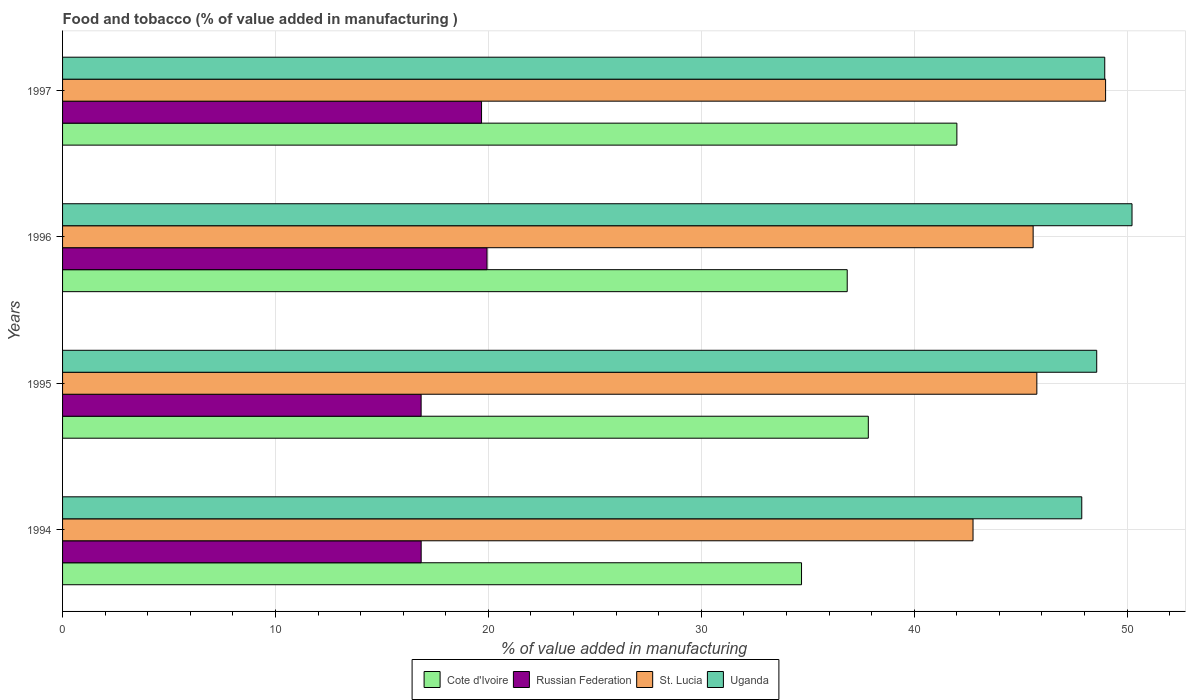How many different coloured bars are there?
Your answer should be very brief. 4. How many groups of bars are there?
Provide a succinct answer. 4. Are the number of bars per tick equal to the number of legend labels?
Ensure brevity in your answer.  Yes. How many bars are there on the 4th tick from the top?
Your answer should be compact. 4. In how many cases, is the number of bars for a given year not equal to the number of legend labels?
Ensure brevity in your answer.  0. What is the value added in manufacturing food and tobacco in Russian Federation in 1997?
Keep it short and to the point. 19.68. Across all years, what is the maximum value added in manufacturing food and tobacco in Uganda?
Make the answer very short. 50.23. Across all years, what is the minimum value added in manufacturing food and tobacco in St. Lucia?
Your answer should be compact. 42.76. In which year was the value added in manufacturing food and tobacco in Uganda maximum?
Your response must be concise. 1996. In which year was the value added in manufacturing food and tobacco in Cote d'Ivoire minimum?
Offer a very short reply. 1994. What is the total value added in manufacturing food and tobacco in Cote d'Ivoire in the graph?
Offer a very short reply. 151.42. What is the difference between the value added in manufacturing food and tobacco in Uganda in 1994 and that in 1995?
Offer a very short reply. -0.7. What is the difference between the value added in manufacturing food and tobacco in Russian Federation in 1994 and the value added in manufacturing food and tobacco in Cote d'Ivoire in 1997?
Offer a very short reply. -25.16. What is the average value added in manufacturing food and tobacco in Cote d'Ivoire per year?
Your answer should be compact. 37.85. In the year 1995, what is the difference between the value added in manufacturing food and tobacco in Cote d'Ivoire and value added in manufacturing food and tobacco in Russian Federation?
Offer a terse response. 21. What is the ratio of the value added in manufacturing food and tobacco in Cote d'Ivoire in 1995 to that in 1996?
Ensure brevity in your answer.  1.03. Is the difference between the value added in manufacturing food and tobacco in Cote d'Ivoire in 1995 and 1997 greater than the difference between the value added in manufacturing food and tobacco in Russian Federation in 1995 and 1997?
Give a very brief answer. No. What is the difference between the highest and the second highest value added in manufacturing food and tobacco in St. Lucia?
Give a very brief answer. 3.23. What is the difference between the highest and the lowest value added in manufacturing food and tobacco in St. Lucia?
Make the answer very short. 6.23. In how many years, is the value added in manufacturing food and tobacco in St. Lucia greater than the average value added in manufacturing food and tobacco in St. Lucia taken over all years?
Give a very brief answer. 1. Is the sum of the value added in manufacturing food and tobacco in Cote d'Ivoire in 1994 and 1995 greater than the maximum value added in manufacturing food and tobacco in Uganda across all years?
Make the answer very short. Yes. Is it the case that in every year, the sum of the value added in manufacturing food and tobacco in Cote d'Ivoire and value added in manufacturing food and tobacco in Uganda is greater than the sum of value added in manufacturing food and tobacco in St. Lucia and value added in manufacturing food and tobacco in Russian Federation?
Offer a terse response. Yes. What does the 2nd bar from the top in 1994 represents?
Provide a short and direct response. St. Lucia. What does the 1st bar from the bottom in 1997 represents?
Your response must be concise. Cote d'Ivoire. Is it the case that in every year, the sum of the value added in manufacturing food and tobacco in Russian Federation and value added in manufacturing food and tobacco in St. Lucia is greater than the value added in manufacturing food and tobacco in Uganda?
Your response must be concise. Yes. What is the difference between two consecutive major ticks on the X-axis?
Give a very brief answer. 10. How are the legend labels stacked?
Offer a very short reply. Horizontal. What is the title of the graph?
Your answer should be compact. Food and tobacco (% of value added in manufacturing ). Does "Mauritania" appear as one of the legend labels in the graph?
Provide a short and direct response. No. What is the label or title of the X-axis?
Provide a short and direct response. % of value added in manufacturing. What is the label or title of the Y-axis?
Provide a succinct answer. Years. What is the % of value added in manufacturing in Cote d'Ivoire in 1994?
Ensure brevity in your answer.  34.71. What is the % of value added in manufacturing of Russian Federation in 1994?
Offer a very short reply. 16.84. What is the % of value added in manufacturing of St. Lucia in 1994?
Your answer should be very brief. 42.76. What is the % of value added in manufacturing in Uganda in 1994?
Ensure brevity in your answer.  47.87. What is the % of value added in manufacturing in Cote d'Ivoire in 1995?
Your response must be concise. 37.85. What is the % of value added in manufacturing of Russian Federation in 1995?
Your answer should be very brief. 16.84. What is the % of value added in manufacturing of St. Lucia in 1995?
Ensure brevity in your answer.  45.76. What is the % of value added in manufacturing in Uganda in 1995?
Your answer should be very brief. 48.57. What is the % of value added in manufacturing in Cote d'Ivoire in 1996?
Your answer should be compact. 36.86. What is the % of value added in manufacturing in Russian Federation in 1996?
Provide a succinct answer. 19.94. What is the % of value added in manufacturing of St. Lucia in 1996?
Provide a short and direct response. 45.59. What is the % of value added in manufacturing of Uganda in 1996?
Provide a short and direct response. 50.23. What is the % of value added in manufacturing of Cote d'Ivoire in 1997?
Provide a short and direct response. 42.01. What is the % of value added in manufacturing in Russian Federation in 1997?
Provide a succinct answer. 19.68. What is the % of value added in manufacturing of St. Lucia in 1997?
Make the answer very short. 48.99. What is the % of value added in manufacturing of Uganda in 1997?
Offer a very short reply. 48.95. Across all years, what is the maximum % of value added in manufacturing of Cote d'Ivoire?
Provide a succinct answer. 42.01. Across all years, what is the maximum % of value added in manufacturing in Russian Federation?
Give a very brief answer. 19.94. Across all years, what is the maximum % of value added in manufacturing of St. Lucia?
Your answer should be compact. 48.99. Across all years, what is the maximum % of value added in manufacturing in Uganda?
Give a very brief answer. 50.23. Across all years, what is the minimum % of value added in manufacturing in Cote d'Ivoire?
Offer a terse response. 34.71. Across all years, what is the minimum % of value added in manufacturing of Russian Federation?
Make the answer very short. 16.84. Across all years, what is the minimum % of value added in manufacturing of St. Lucia?
Make the answer very short. 42.76. Across all years, what is the minimum % of value added in manufacturing of Uganda?
Keep it short and to the point. 47.87. What is the total % of value added in manufacturing of Cote d'Ivoire in the graph?
Your response must be concise. 151.42. What is the total % of value added in manufacturing in Russian Federation in the graph?
Provide a succinct answer. 73.3. What is the total % of value added in manufacturing in St. Lucia in the graph?
Your answer should be compact. 183.11. What is the total % of value added in manufacturing of Uganda in the graph?
Make the answer very short. 195.63. What is the difference between the % of value added in manufacturing in Cote d'Ivoire in 1994 and that in 1995?
Provide a short and direct response. -3.14. What is the difference between the % of value added in manufacturing of Russian Federation in 1994 and that in 1995?
Make the answer very short. 0. What is the difference between the % of value added in manufacturing in St. Lucia in 1994 and that in 1995?
Your response must be concise. -3. What is the difference between the % of value added in manufacturing of Uganda in 1994 and that in 1995?
Your answer should be compact. -0.7. What is the difference between the % of value added in manufacturing of Cote d'Ivoire in 1994 and that in 1996?
Your answer should be very brief. -2.15. What is the difference between the % of value added in manufacturing in Russian Federation in 1994 and that in 1996?
Offer a very short reply. -3.09. What is the difference between the % of value added in manufacturing of St. Lucia in 1994 and that in 1996?
Offer a terse response. -2.82. What is the difference between the % of value added in manufacturing of Uganda in 1994 and that in 1996?
Ensure brevity in your answer.  -2.36. What is the difference between the % of value added in manufacturing of Cote d'Ivoire in 1994 and that in 1997?
Keep it short and to the point. -7.3. What is the difference between the % of value added in manufacturing in Russian Federation in 1994 and that in 1997?
Give a very brief answer. -2.84. What is the difference between the % of value added in manufacturing of St. Lucia in 1994 and that in 1997?
Provide a short and direct response. -6.23. What is the difference between the % of value added in manufacturing in Uganda in 1994 and that in 1997?
Provide a succinct answer. -1.08. What is the difference between the % of value added in manufacturing of Russian Federation in 1995 and that in 1996?
Ensure brevity in your answer.  -3.1. What is the difference between the % of value added in manufacturing of St. Lucia in 1995 and that in 1996?
Your answer should be compact. 0.17. What is the difference between the % of value added in manufacturing in Uganda in 1995 and that in 1996?
Offer a very short reply. -1.66. What is the difference between the % of value added in manufacturing of Cote d'Ivoire in 1995 and that in 1997?
Your response must be concise. -4.16. What is the difference between the % of value added in manufacturing in Russian Federation in 1995 and that in 1997?
Your answer should be very brief. -2.84. What is the difference between the % of value added in manufacturing in St. Lucia in 1995 and that in 1997?
Provide a short and direct response. -3.23. What is the difference between the % of value added in manufacturing of Uganda in 1995 and that in 1997?
Offer a terse response. -0.38. What is the difference between the % of value added in manufacturing of Cote d'Ivoire in 1996 and that in 1997?
Offer a very short reply. -5.15. What is the difference between the % of value added in manufacturing in Russian Federation in 1996 and that in 1997?
Ensure brevity in your answer.  0.26. What is the difference between the % of value added in manufacturing in St. Lucia in 1996 and that in 1997?
Give a very brief answer. -3.4. What is the difference between the % of value added in manufacturing in Uganda in 1996 and that in 1997?
Keep it short and to the point. 1.28. What is the difference between the % of value added in manufacturing of Cote d'Ivoire in 1994 and the % of value added in manufacturing of Russian Federation in 1995?
Provide a succinct answer. 17.87. What is the difference between the % of value added in manufacturing of Cote d'Ivoire in 1994 and the % of value added in manufacturing of St. Lucia in 1995?
Keep it short and to the point. -11.05. What is the difference between the % of value added in manufacturing of Cote d'Ivoire in 1994 and the % of value added in manufacturing of Uganda in 1995?
Give a very brief answer. -13.87. What is the difference between the % of value added in manufacturing of Russian Federation in 1994 and the % of value added in manufacturing of St. Lucia in 1995?
Ensure brevity in your answer.  -28.92. What is the difference between the % of value added in manufacturing of Russian Federation in 1994 and the % of value added in manufacturing of Uganda in 1995?
Offer a very short reply. -31.73. What is the difference between the % of value added in manufacturing of St. Lucia in 1994 and the % of value added in manufacturing of Uganda in 1995?
Offer a terse response. -5.81. What is the difference between the % of value added in manufacturing in Cote d'Ivoire in 1994 and the % of value added in manufacturing in Russian Federation in 1996?
Your answer should be compact. 14.77. What is the difference between the % of value added in manufacturing of Cote d'Ivoire in 1994 and the % of value added in manufacturing of St. Lucia in 1996?
Give a very brief answer. -10.88. What is the difference between the % of value added in manufacturing of Cote d'Ivoire in 1994 and the % of value added in manufacturing of Uganda in 1996?
Offer a terse response. -15.52. What is the difference between the % of value added in manufacturing in Russian Federation in 1994 and the % of value added in manufacturing in St. Lucia in 1996?
Keep it short and to the point. -28.74. What is the difference between the % of value added in manufacturing in Russian Federation in 1994 and the % of value added in manufacturing in Uganda in 1996?
Make the answer very short. -33.39. What is the difference between the % of value added in manufacturing in St. Lucia in 1994 and the % of value added in manufacturing in Uganda in 1996?
Your response must be concise. -7.47. What is the difference between the % of value added in manufacturing in Cote d'Ivoire in 1994 and the % of value added in manufacturing in Russian Federation in 1997?
Keep it short and to the point. 15.03. What is the difference between the % of value added in manufacturing of Cote d'Ivoire in 1994 and the % of value added in manufacturing of St. Lucia in 1997?
Give a very brief answer. -14.28. What is the difference between the % of value added in manufacturing of Cote d'Ivoire in 1994 and the % of value added in manufacturing of Uganda in 1997?
Keep it short and to the point. -14.24. What is the difference between the % of value added in manufacturing of Russian Federation in 1994 and the % of value added in manufacturing of St. Lucia in 1997?
Your answer should be very brief. -32.15. What is the difference between the % of value added in manufacturing in Russian Federation in 1994 and the % of value added in manufacturing in Uganda in 1997?
Your response must be concise. -32.11. What is the difference between the % of value added in manufacturing in St. Lucia in 1994 and the % of value added in manufacturing in Uganda in 1997?
Provide a short and direct response. -6.19. What is the difference between the % of value added in manufacturing in Cote d'Ivoire in 1995 and the % of value added in manufacturing in Russian Federation in 1996?
Your answer should be compact. 17.91. What is the difference between the % of value added in manufacturing of Cote d'Ivoire in 1995 and the % of value added in manufacturing of St. Lucia in 1996?
Your answer should be very brief. -7.74. What is the difference between the % of value added in manufacturing of Cote d'Ivoire in 1995 and the % of value added in manufacturing of Uganda in 1996?
Give a very brief answer. -12.39. What is the difference between the % of value added in manufacturing in Russian Federation in 1995 and the % of value added in manufacturing in St. Lucia in 1996?
Offer a terse response. -28.75. What is the difference between the % of value added in manufacturing in Russian Federation in 1995 and the % of value added in manufacturing in Uganda in 1996?
Give a very brief answer. -33.39. What is the difference between the % of value added in manufacturing of St. Lucia in 1995 and the % of value added in manufacturing of Uganda in 1996?
Offer a very short reply. -4.47. What is the difference between the % of value added in manufacturing in Cote d'Ivoire in 1995 and the % of value added in manufacturing in Russian Federation in 1997?
Give a very brief answer. 18.17. What is the difference between the % of value added in manufacturing in Cote d'Ivoire in 1995 and the % of value added in manufacturing in St. Lucia in 1997?
Offer a very short reply. -11.14. What is the difference between the % of value added in manufacturing of Cote d'Ivoire in 1995 and the % of value added in manufacturing of Uganda in 1997?
Ensure brevity in your answer.  -11.11. What is the difference between the % of value added in manufacturing of Russian Federation in 1995 and the % of value added in manufacturing of St. Lucia in 1997?
Make the answer very short. -32.15. What is the difference between the % of value added in manufacturing in Russian Federation in 1995 and the % of value added in manufacturing in Uganda in 1997?
Your answer should be very brief. -32.11. What is the difference between the % of value added in manufacturing in St. Lucia in 1995 and the % of value added in manufacturing in Uganda in 1997?
Provide a short and direct response. -3.19. What is the difference between the % of value added in manufacturing in Cote d'Ivoire in 1996 and the % of value added in manufacturing in Russian Federation in 1997?
Offer a very short reply. 17.18. What is the difference between the % of value added in manufacturing of Cote d'Ivoire in 1996 and the % of value added in manufacturing of St. Lucia in 1997?
Offer a very short reply. -12.14. What is the difference between the % of value added in manufacturing of Cote d'Ivoire in 1996 and the % of value added in manufacturing of Uganda in 1997?
Offer a terse response. -12.1. What is the difference between the % of value added in manufacturing of Russian Federation in 1996 and the % of value added in manufacturing of St. Lucia in 1997?
Your response must be concise. -29.05. What is the difference between the % of value added in manufacturing in Russian Federation in 1996 and the % of value added in manufacturing in Uganda in 1997?
Keep it short and to the point. -29.01. What is the difference between the % of value added in manufacturing in St. Lucia in 1996 and the % of value added in manufacturing in Uganda in 1997?
Offer a terse response. -3.36. What is the average % of value added in manufacturing of Cote d'Ivoire per year?
Give a very brief answer. 37.85. What is the average % of value added in manufacturing of Russian Federation per year?
Offer a very short reply. 18.33. What is the average % of value added in manufacturing in St. Lucia per year?
Offer a terse response. 45.78. What is the average % of value added in manufacturing in Uganda per year?
Your answer should be compact. 48.91. In the year 1994, what is the difference between the % of value added in manufacturing in Cote d'Ivoire and % of value added in manufacturing in Russian Federation?
Give a very brief answer. 17.87. In the year 1994, what is the difference between the % of value added in manufacturing in Cote d'Ivoire and % of value added in manufacturing in St. Lucia?
Ensure brevity in your answer.  -8.06. In the year 1994, what is the difference between the % of value added in manufacturing of Cote d'Ivoire and % of value added in manufacturing of Uganda?
Keep it short and to the point. -13.16. In the year 1994, what is the difference between the % of value added in manufacturing in Russian Federation and % of value added in manufacturing in St. Lucia?
Provide a succinct answer. -25.92. In the year 1994, what is the difference between the % of value added in manufacturing in Russian Federation and % of value added in manufacturing in Uganda?
Offer a very short reply. -31.03. In the year 1994, what is the difference between the % of value added in manufacturing in St. Lucia and % of value added in manufacturing in Uganda?
Offer a terse response. -5.11. In the year 1995, what is the difference between the % of value added in manufacturing of Cote d'Ivoire and % of value added in manufacturing of Russian Federation?
Offer a very short reply. 21. In the year 1995, what is the difference between the % of value added in manufacturing of Cote d'Ivoire and % of value added in manufacturing of St. Lucia?
Give a very brief answer. -7.92. In the year 1995, what is the difference between the % of value added in manufacturing of Cote d'Ivoire and % of value added in manufacturing of Uganda?
Your answer should be compact. -10.73. In the year 1995, what is the difference between the % of value added in manufacturing of Russian Federation and % of value added in manufacturing of St. Lucia?
Provide a succinct answer. -28.92. In the year 1995, what is the difference between the % of value added in manufacturing of Russian Federation and % of value added in manufacturing of Uganda?
Keep it short and to the point. -31.73. In the year 1995, what is the difference between the % of value added in manufacturing in St. Lucia and % of value added in manufacturing in Uganda?
Offer a very short reply. -2.81. In the year 1996, what is the difference between the % of value added in manufacturing of Cote d'Ivoire and % of value added in manufacturing of Russian Federation?
Keep it short and to the point. 16.92. In the year 1996, what is the difference between the % of value added in manufacturing in Cote d'Ivoire and % of value added in manufacturing in St. Lucia?
Ensure brevity in your answer.  -8.73. In the year 1996, what is the difference between the % of value added in manufacturing of Cote d'Ivoire and % of value added in manufacturing of Uganda?
Give a very brief answer. -13.38. In the year 1996, what is the difference between the % of value added in manufacturing in Russian Federation and % of value added in manufacturing in St. Lucia?
Your answer should be compact. -25.65. In the year 1996, what is the difference between the % of value added in manufacturing in Russian Federation and % of value added in manufacturing in Uganda?
Give a very brief answer. -30.3. In the year 1996, what is the difference between the % of value added in manufacturing of St. Lucia and % of value added in manufacturing of Uganda?
Your answer should be compact. -4.64. In the year 1997, what is the difference between the % of value added in manufacturing of Cote d'Ivoire and % of value added in manufacturing of Russian Federation?
Your answer should be very brief. 22.33. In the year 1997, what is the difference between the % of value added in manufacturing in Cote d'Ivoire and % of value added in manufacturing in St. Lucia?
Provide a succinct answer. -6.99. In the year 1997, what is the difference between the % of value added in manufacturing of Cote d'Ivoire and % of value added in manufacturing of Uganda?
Keep it short and to the point. -6.95. In the year 1997, what is the difference between the % of value added in manufacturing of Russian Federation and % of value added in manufacturing of St. Lucia?
Offer a very short reply. -29.31. In the year 1997, what is the difference between the % of value added in manufacturing in Russian Federation and % of value added in manufacturing in Uganda?
Keep it short and to the point. -29.27. In the year 1997, what is the difference between the % of value added in manufacturing in St. Lucia and % of value added in manufacturing in Uganda?
Ensure brevity in your answer.  0.04. What is the ratio of the % of value added in manufacturing in Cote d'Ivoire in 1994 to that in 1995?
Ensure brevity in your answer.  0.92. What is the ratio of the % of value added in manufacturing in Russian Federation in 1994 to that in 1995?
Provide a succinct answer. 1. What is the ratio of the % of value added in manufacturing in St. Lucia in 1994 to that in 1995?
Provide a succinct answer. 0.93. What is the ratio of the % of value added in manufacturing in Uganda in 1994 to that in 1995?
Provide a succinct answer. 0.99. What is the ratio of the % of value added in manufacturing in Cote d'Ivoire in 1994 to that in 1996?
Your response must be concise. 0.94. What is the ratio of the % of value added in manufacturing of Russian Federation in 1994 to that in 1996?
Your answer should be very brief. 0.84. What is the ratio of the % of value added in manufacturing of St. Lucia in 1994 to that in 1996?
Keep it short and to the point. 0.94. What is the ratio of the % of value added in manufacturing in Uganda in 1994 to that in 1996?
Offer a terse response. 0.95. What is the ratio of the % of value added in manufacturing of Cote d'Ivoire in 1994 to that in 1997?
Give a very brief answer. 0.83. What is the ratio of the % of value added in manufacturing in Russian Federation in 1994 to that in 1997?
Your answer should be very brief. 0.86. What is the ratio of the % of value added in manufacturing of St. Lucia in 1994 to that in 1997?
Keep it short and to the point. 0.87. What is the ratio of the % of value added in manufacturing in Uganda in 1994 to that in 1997?
Your answer should be very brief. 0.98. What is the ratio of the % of value added in manufacturing of Cote d'Ivoire in 1995 to that in 1996?
Give a very brief answer. 1.03. What is the ratio of the % of value added in manufacturing of Russian Federation in 1995 to that in 1996?
Your answer should be compact. 0.84. What is the ratio of the % of value added in manufacturing in St. Lucia in 1995 to that in 1996?
Keep it short and to the point. 1. What is the ratio of the % of value added in manufacturing of Uganda in 1995 to that in 1996?
Provide a succinct answer. 0.97. What is the ratio of the % of value added in manufacturing of Cote d'Ivoire in 1995 to that in 1997?
Keep it short and to the point. 0.9. What is the ratio of the % of value added in manufacturing of Russian Federation in 1995 to that in 1997?
Make the answer very short. 0.86. What is the ratio of the % of value added in manufacturing in St. Lucia in 1995 to that in 1997?
Your answer should be very brief. 0.93. What is the ratio of the % of value added in manufacturing in Cote d'Ivoire in 1996 to that in 1997?
Offer a terse response. 0.88. What is the ratio of the % of value added in manufacturing in Russian Federation in 1996 to that in 1997?
Make the answer very short. 1.01. What is the ratio of the % of value added in manufacturing of St. Lucia in 1996 to that in 1997?
Your answer should be very brief. 0.93. What is the ratio of the % of value added in manufacturing in Uganda in 1996 to that in 1997?
Keep it short and to the point. 1.03. What is the difference between the highest and the second highest % of value added in manufacturing of Cote d'Ivoire?
Make the answer very short. 4.16. What is the difference between the highest and the second highest % of value added in manufacturing of Russian Federation?
Offer a very short reply. 0.26. What is the difference between the highest and the second highest % of value added in manufacturing of St. Lucia?
Keep it short and to the point. 3.23. What is the difference between the highest and the second highest % of value added in manufacturing of Uganda?
Your answer should be very brief. 1.28. What is the difference between the highest and the lowest % of value added in manufacturing of Cote d'Ivoire?
Provide a succinct answer. 7.3. What is the difference between the highest and the lowest % of value added in manufacturing in Russian Federation?
Make the answer very short. 3.1. What is the difference between the highest and the lowest % of value added in manufacturing in St. Lucia?
Keep it short and to the point. 6.23. What is the difference between the highest and the lowest % of value added in manufacturing in Uganda?
Your answer should be very brief. 2.36. 